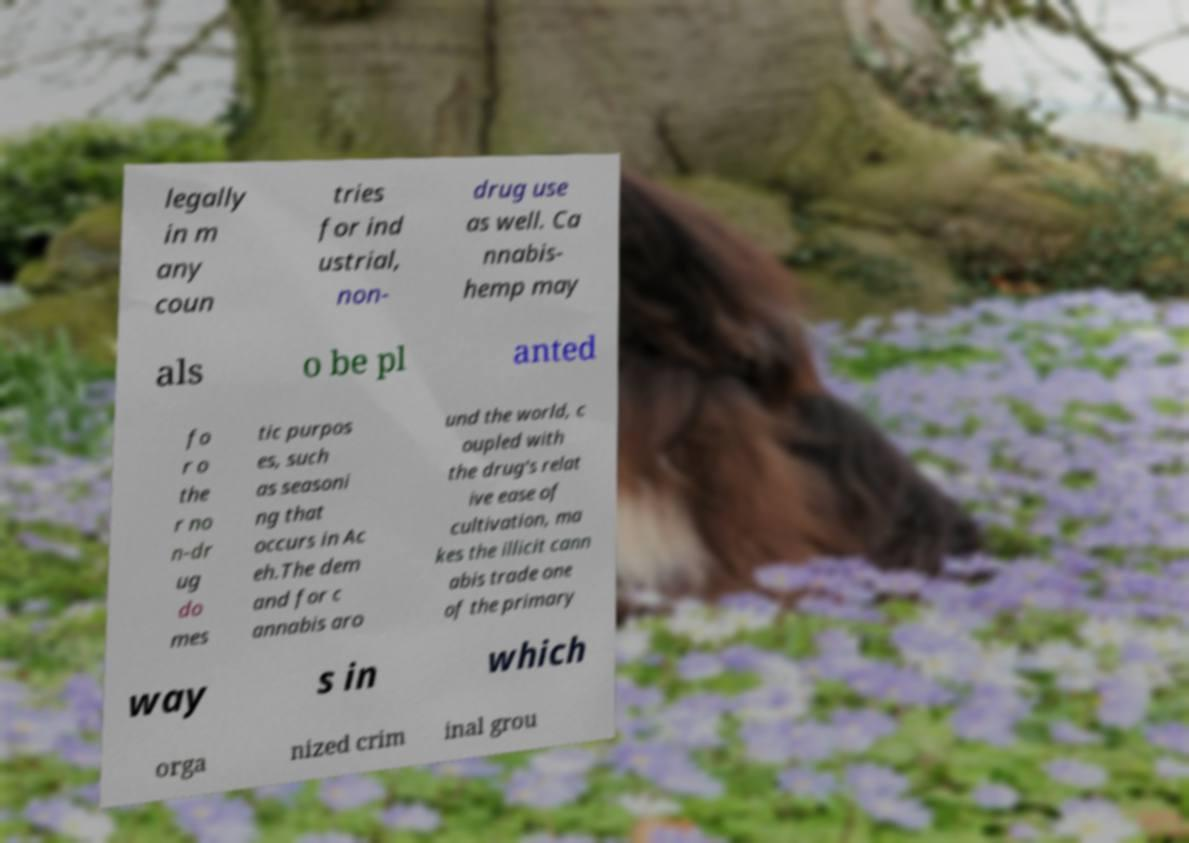Could you assist in decoding the text presented in this image and type it out clearly? legally in m any coun tries for ind ustrial, non- drug use as well. Ca nnabis- hemp may als o be pl anted fo r o the r no n-dr ug do mes tic purpos es, such as seasoni ng that occurs in Ac eh.The dem and for c annabis aro und the world, c oupled with the drug's relat ive ease of cultivation, ma kes the illicit cann abis trade one of the primary way s in which orga nized crim inal grou 